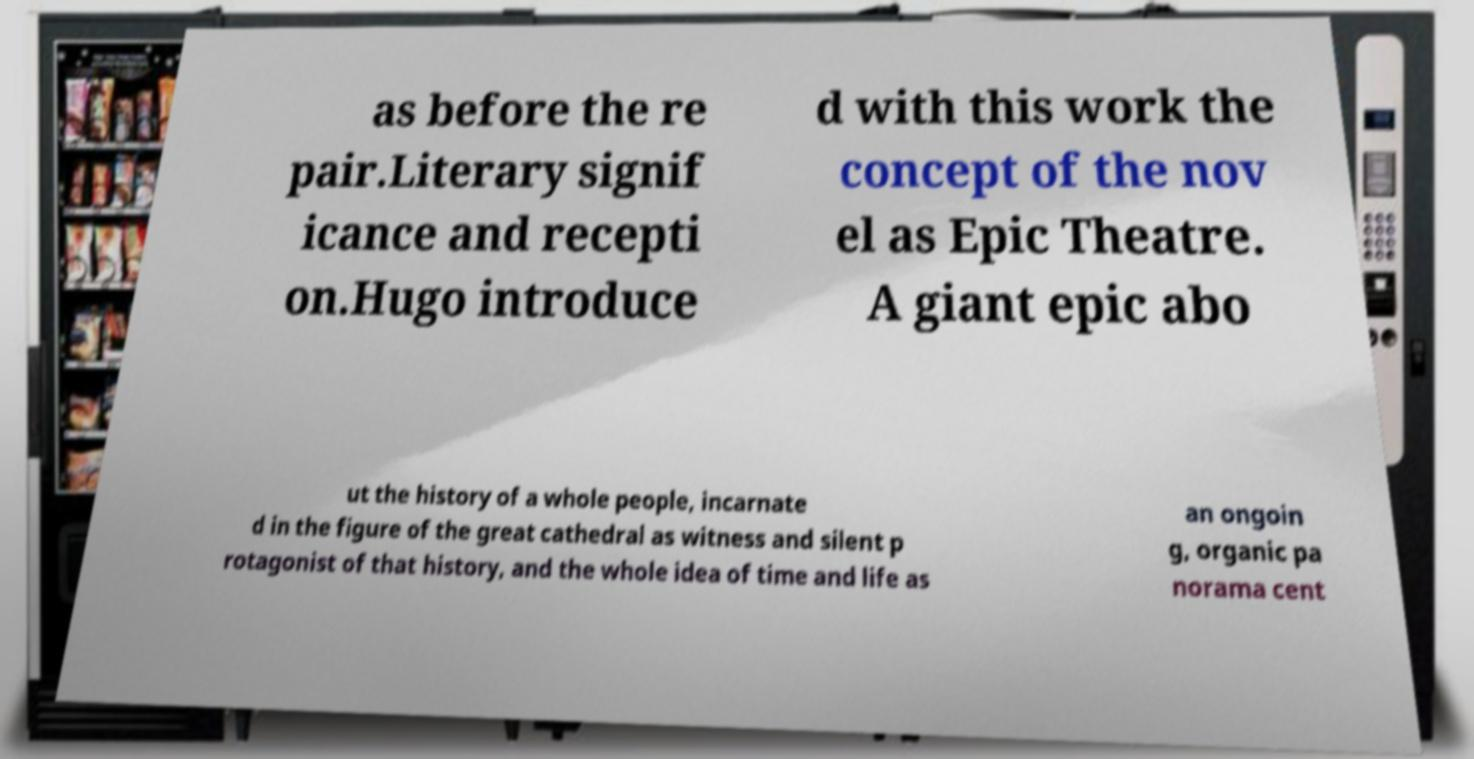I need the written content from this picture converted into text. Can you do that? as before the re pair.Literary signif icance and recepti on.Hugo introduce d with this work the concept of the nov el as Epic Theatre. A giant epic abo ut the history of a whole people, incarnate d in the figure of the great cathedral as witness and silent p rotagonist of that history, and the whole idea of time and life as an ongoin g, organic pa norama cent 